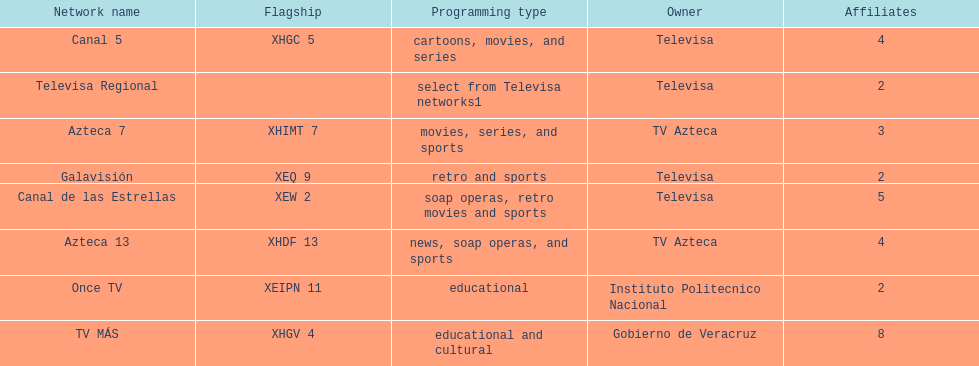Who has the most number of affiliates? TV MÁS. 